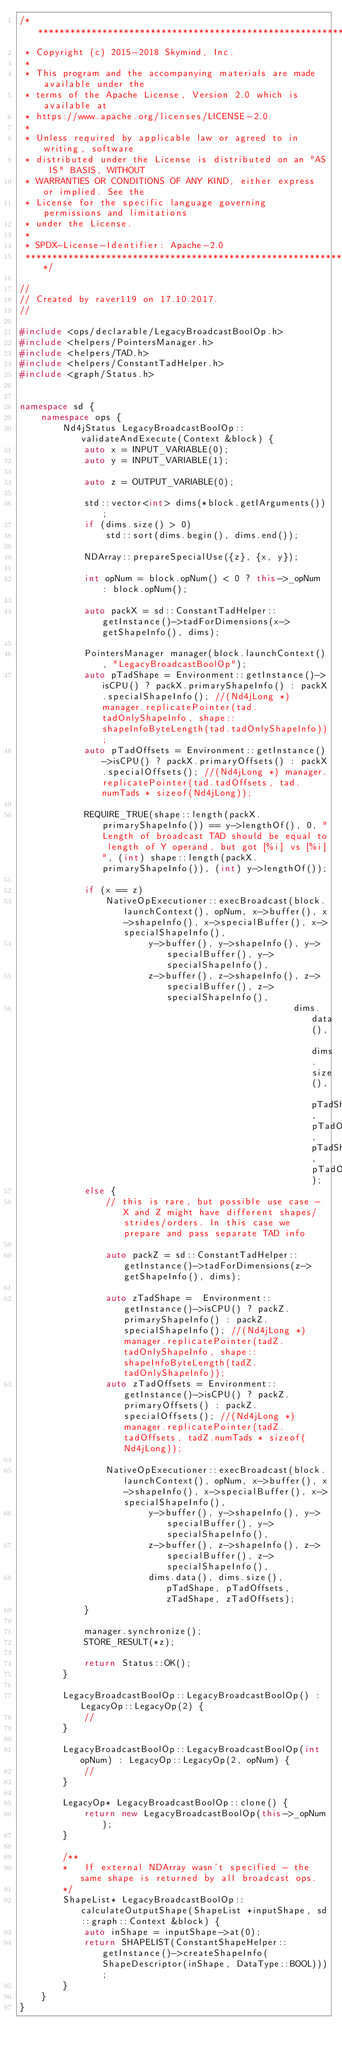<code> <loc_0><loc_0><loc_500><loc_500><_C++_>/*******************************************************************************
 * Copyright (c) 2015-2018 Skymind, Inc.
 *
 * This program and the accompanying materials are made available under the
 * terms of the Apache License, Version 2.0 which is available at
 * https://www.apache.org/licenses/LICENSE-2.0.
 *
 * Unless required by applicable law or agreed to in writing, software
 * distributed under the License is distributed on an "AS IS" BASIS, WITHOUT
 * WARRANTIES OR CONDITIONS OF ANY KIND, either express or implied. See the
 * License for the specific language governing permissions and limitations
 * under the License.
 *
 * SPDX-License-Identifier: Apache-2.0
 ******************************************************************************/

//
// Created by raver119 on 17.10.2017.
//

#include <ops/declarable/LegacyBroadcastBoolOp.h>
#include <helpers/PointersManager.h>
#include <helpers/TAD.h>
#include <helpers/ConstantTadHelper.h>
#include <graph/Status.h>


namespace sd {
    namespace ops {
        Nd4jStatus LegacyBroadcastBoolOp::validateAndExecute(Context &block) {
            auto x = INPUT_VARIABLE(0);
            auto y = INPUT_VARIABLE(1);

            auto z = OUTPUT_VARIABLE(0);

            std::vector<int> dims(*block.getIArguments());
            if (dims.size() > 0)
                std::sort(dims.begin(), dims.end());

            NDArray::prepareSpecialUse({z}, {x, y});

            int opNum = block.opNum() < 0 ? this->_opNum : block.opNum();

            auto packX = sd::ConstantTadHelper::getInstance()->tadForDimensions(x->getShapeInfo(), dims);

            PointersManager manager(block.launchContext(), "LegacyBroadcastBoolOp");
            auto pTadShape = Environment::getInstance()->isCPU() ? packX.primaryShapeInfo() : packX.specialShapeInfo(); //(Nd4jLong *) manager.replicatePointer(tad.tadOnlyShapeInfo, shape::shapeInfoByteLength(tad.tadOnlyShapeInfo));
            auto pTadOffsets = Environment::getInstance()->isCPU() ? packX.primaryOffsets() : packX.specialOffsets(); //(Nd4jLong *) manager.replicatePointer(tad.tadOffsets, tad.numTads * sizeof(Nd4jLong));

            REQUIRE_TRUE(shape::length(packX.primaryShapeInfo()) == y->lengthOf(), 0, "Length of broadcast TAD should be equal to length of Y operand, but got [%i] vs [%i]", (int) shape::length(packX.primaryShapeInfo()), (int) y->lengthOf());

            if (x == z)
                NativeOpExecutioner::execBroadcast(block.launchContext(), opNum, x->buffer(), x->shapeInfo(), x->specialBuffer(), x->specialShapeInfo(),
                        y->buffer(), y->shapeInfo(), y->specialBuffer(), y->specialShapeInfo(),
                        z->buffer(), z->shapeInfo(), z->specialBuffer(), z->specialShapeInfo(),
                                                   dims.data(), dims.size(), pTadShape, pTadOffsets, pTadShape, pTadOffsets);
            else {
                // this is rare, but possible use case - X and Z might have different shapes/strides/orders. In this case we prepare and pass separate TAD info

                auto packZ = sd::ConstantTadHelper::getInstance()->tadForDimensions(z->getShapeInfo(), dims);

                auto zTadShape =  Environment::getInstance()->isCPU() ? packZ.primaryShapeInfo() : packZ.specialShapeInfo(); //(Nd4jLong *) manager.replicatePointer(tadZ.tadOnlyShapeInfo, shape::shapeInfoByteLength(tadZ.tadOnlyShapeInfo));
                auto zTadOffsets = Environment::getInstance()->isCPU() ? packZ.primaryOffsets() : packZ.specialOffsets(); //(Nd4jLong *) manager.replicatePointer(tadZ.tadOffsets, tadZ.numTads * sizeof(Nd4jLong));

                NativeOpExecutioner::execBroadcast(block.launchContext(), opNum, x->buffer(), x->shapeInfo(), x->specialBuffer(), x->specialShapeInfo(),
                        y->buffer(), y->shapeInfo(), y->specialBuffer(), y->specialShapeInfo(),
                        z->buffer(), z->shapeInfo(), z->specialBuffer(), z->specialShapeInfo(),
                        dims.data(), dims.size(), pTadShape, pTadOffsets, zTadShape, zTadOffsets);
            }

            manager.synchronize();
            STORE_RESULT(*z);

            return Status::OK();
        }

        LegacyBroadcastBoolOp::LegacyBroadcastBoolOp() : LegacyOp::LegacyOp(2) {
            //
        }

        LegacyBroadcastBoolOp::LegacyBroadcastBoolOp(int opNum) : LegacyOp::LegacyOp(2, opNum) {
            //
        }

        LegacyOp* LegacyBroadcastBoolOp::clone() {
            return new LegacyBroadcastBoolOp(this->_opNum);
        }

        /**
        *   If external NDArray wasn't specified - the same shape is returned by all broadcast ops.
        */
        ShapeList* LegacyBroadcastBoolOp::calculateOutputShape(ShapeList *inputShape, sd::graph::Context &block) {
            auto inShape = inputShape->at(0);
            return SHAPELIST(ConstantShapeHelper::getInstance()->createShapeInfo(ShapeDescriptor(inShape, DataType::BOOL)));
        }
    }
}
</code> 